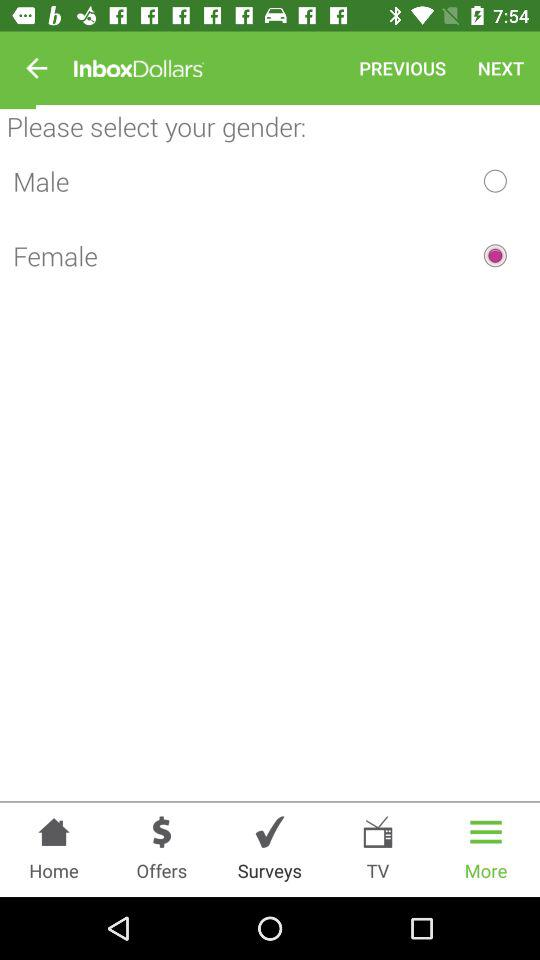Which tab is currently selected?
When the provided information is insufficient, respond with <no answer>. <no answer> 